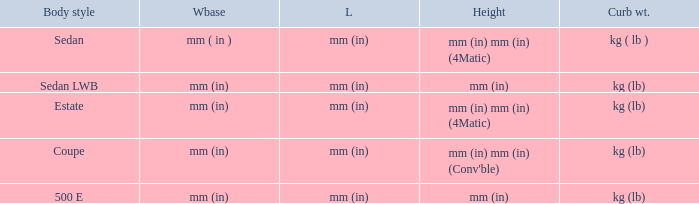What's the length of the model with 500 E body style? Mm (in). 